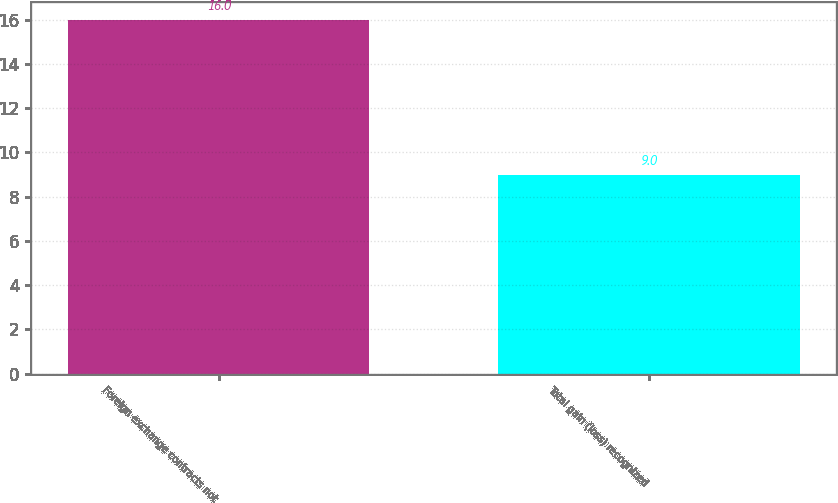<chart> <loc_0><loc_0><loc_500><loc_500><bar_chart><fcel>Foreign exchange contracts not<fcel>Total gain (loss) recognized<nl><fcel>16<fcel>9<nl></chart> 